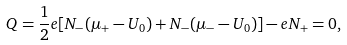<formula> <loc_0><loc_0><loc_500><loc_500>Q = \frac { 1 } { 2 } e [ N _ { - } ( \mu _ { + } - U _ { 0 } ) + N _ { - } ( \mu _ { - } - U _ { 0 } ) ] - e N _ { + } = 0 ,</formula> 